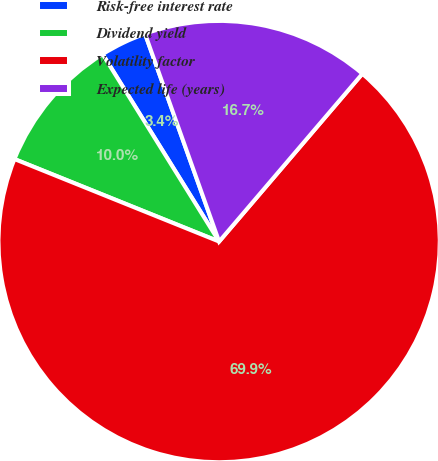<chart> <loc_0><loc_0><loc_500><loc_500><pie_chart><fcel>Risk-free interest rate<fcel>Dividend yield<fcel>Volatility factor<fcel>Expected life (years)<nl><fcel>3.4%<fcel>10.05%<fcel>69.86%<fcel>16.7%<nl></chart> 